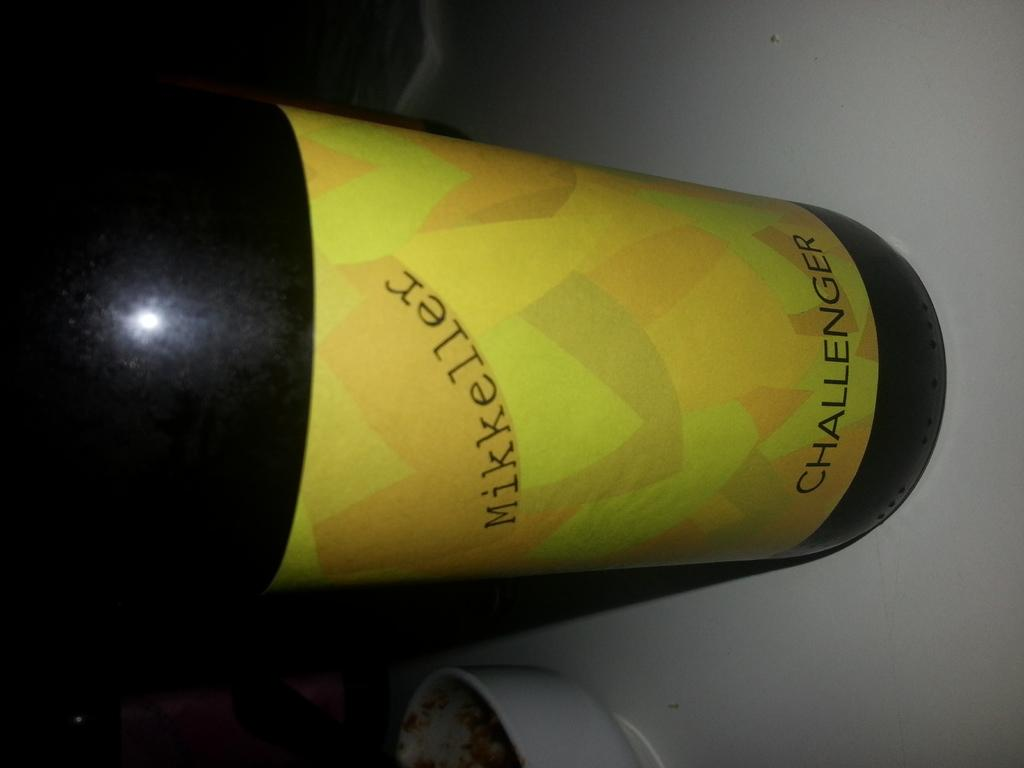What object can be seen in the image? There is a bottle in the image. What is the color of the bottle? The bottle is black in color. Is there any additional detail on the bottle? Yes, there is a yellow color sticker on the bottle. What information can be found on the sticker? Text is written on the sticker. What type of destruction is depicted on the bottle in the image? There is no destruction depicted on the bottle in the image; it is a bottle with a sticker and text. What emotion is the bottle feeling in the image? Bottles do not have emotions, so this question cannot be answered. 